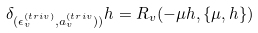<formula> <loc_0><loc_0><loc_500><loc_500>\delta _ { ( \epsilon ^ { ( t r i v ) } _ { v } , a _ { v } ^ { ( t r i v } ) ) } h = R _ { v } ( - \mu h , \{ \mu , h \} )</formula> 